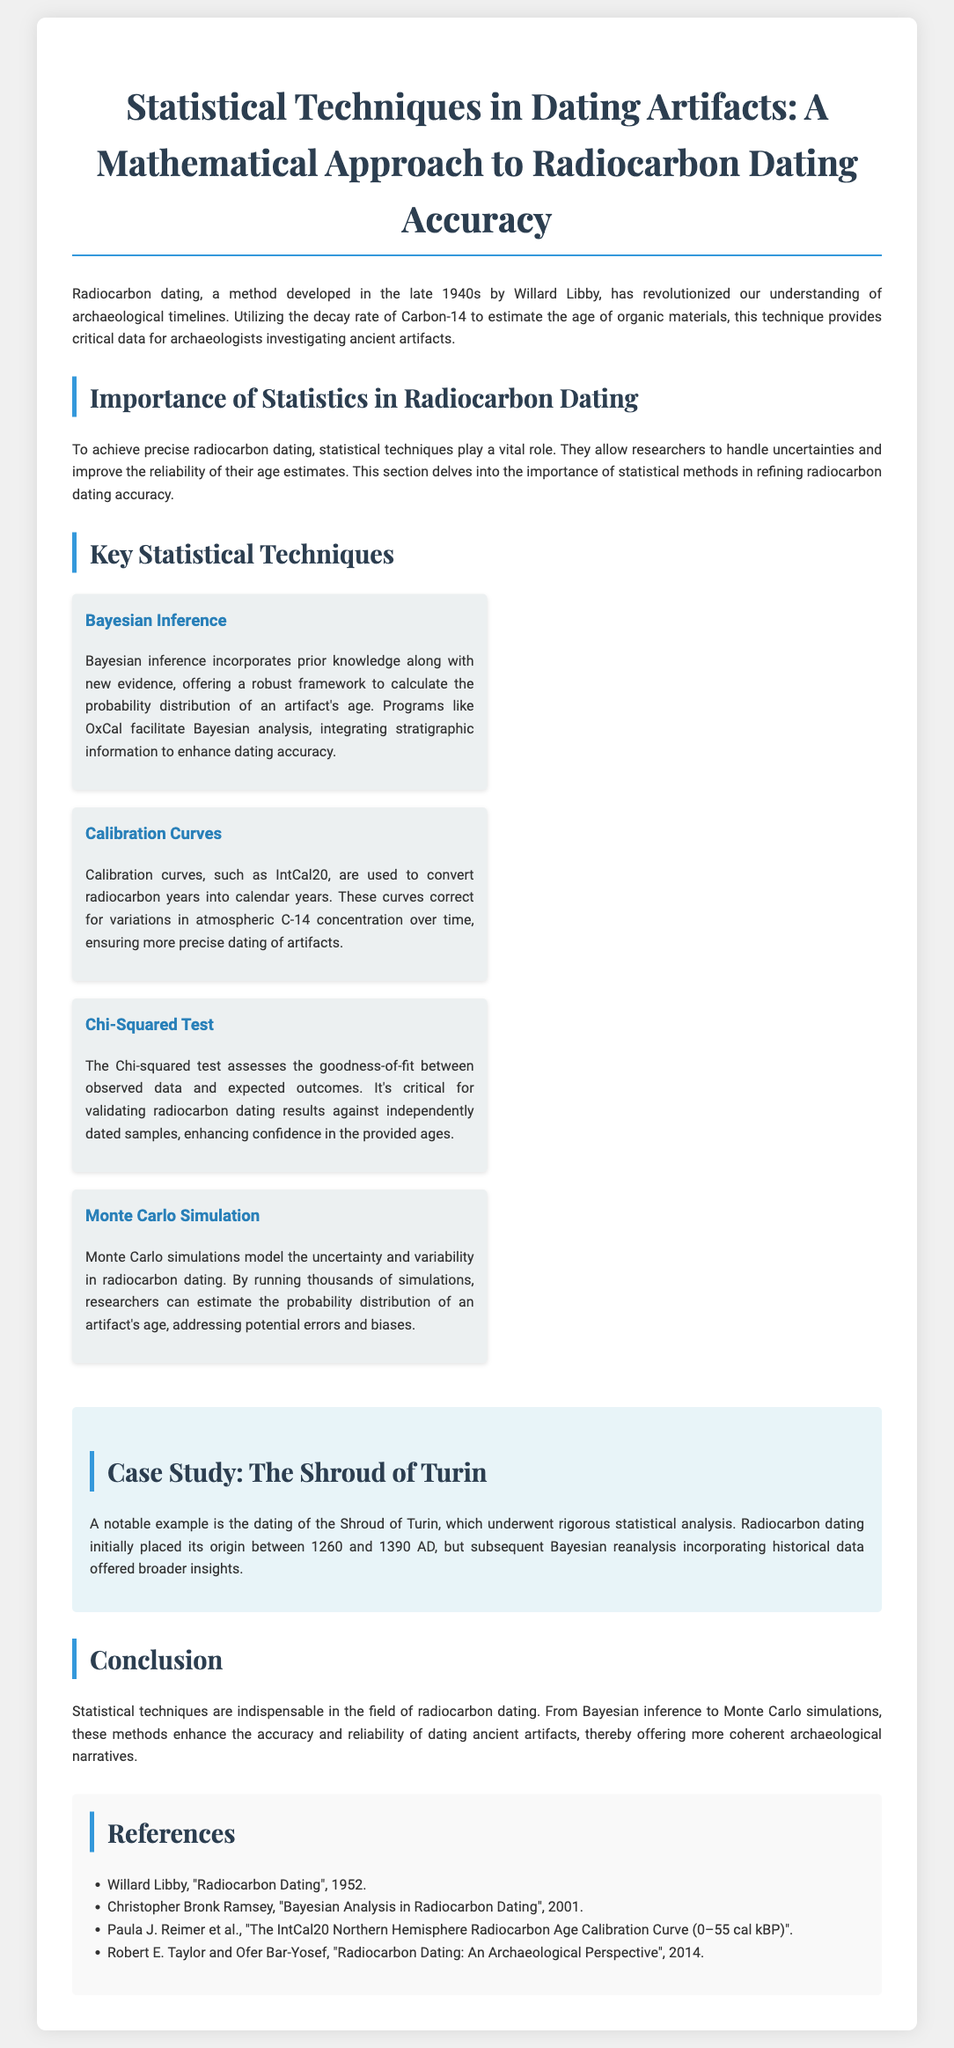What year did Willard Libby develop radiocarbon dating? The document states that radiocarbon dating was developed in the late 1940s by Willard Libby, specifically in 1940.
Answer: 1940 What statistical technique incorporates prior knowledge with new evidence? The document mentions Bayesian inference as the technique that integrates prior knowledge and new evidence for estimating the probability distribution.
Answer: Bayesian inference What is the purpose of calibration curves in radiocarbon dating? The document explains that calibration curves are used to convert radiocarbon years into calendar years, correcting for variations in atmospheric C-14 concentration.
Answer: Convert radiocarbon years into calendar years How does the Chi-squared test contribute to radiocarbon dating? According to the document, the Chi-squared test assesses the goodness-of-fit between observed data and expected outcomes, validating dating results against independently dated samples.
Answer: Validating dating results What notable artifact was dated in the case study? The document refers to the Shroud of Turin as the artifact that underwent rigorous statistical analysis for dating.
Answer: Shroud of Turin What method enhances dating accuracy by running thousands of simulations? The document states that Monte Carlo simulations are used to model uncertainty and variability in radiocarbon dating, running thousands of simulations.
Answer: Monte Carlo simulations What publication year is associated with the "Bayesian Analysis in Radiocarbon Dating"? The document lists the publication year for Christopher Bronk Ramsey's work as 2001.
Answer: 2001 What is the key benefit of using statistical techniques in radiocarbon dating? The document concludes that statistical techniques enhance the accuracy and reliability of dating ancient artifacts.
Answer: Accuracy and reliability 